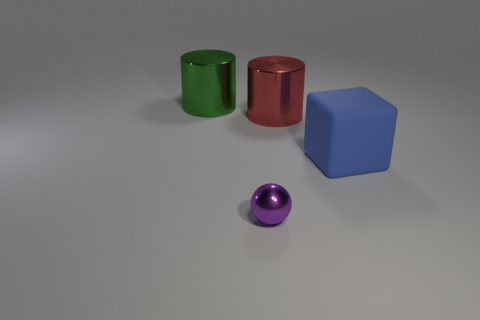Are there an equal number of small metallic things right of the blue thing and blue rubber cubes?
Ensure brevity in your answer.  No. What is the color of the ball?
Keep it short and to the point. Purple. What is the size of the green cylinder that is the same material as the purple thing?
Provide a short and direct response. Large. There is a tiny sphere that is the same material as the green thing; what is its color?
Keep it short and to the point. Purple. Are there any purple objects that have the same size as the ball?
Your answer should be compact. No. There is a large green object that is the same shape as the red object; what is it made of?
Give a very brief answer. Metal. There is another red object that is the same size as the rubber thing; what is its shape?
Keep it short and to the point. Cylinder. Are there any purple metallic objects that have the same shape as the large green thing?
Ensure brevity in your answer.  No. The large thing that is to the left of the big metal cylinder that is right of the tiny purple object is what shape?
Give a very brief answer. Cylinder. What is the shape of the tiny object?
Provide a succinct answer. Sphere. 